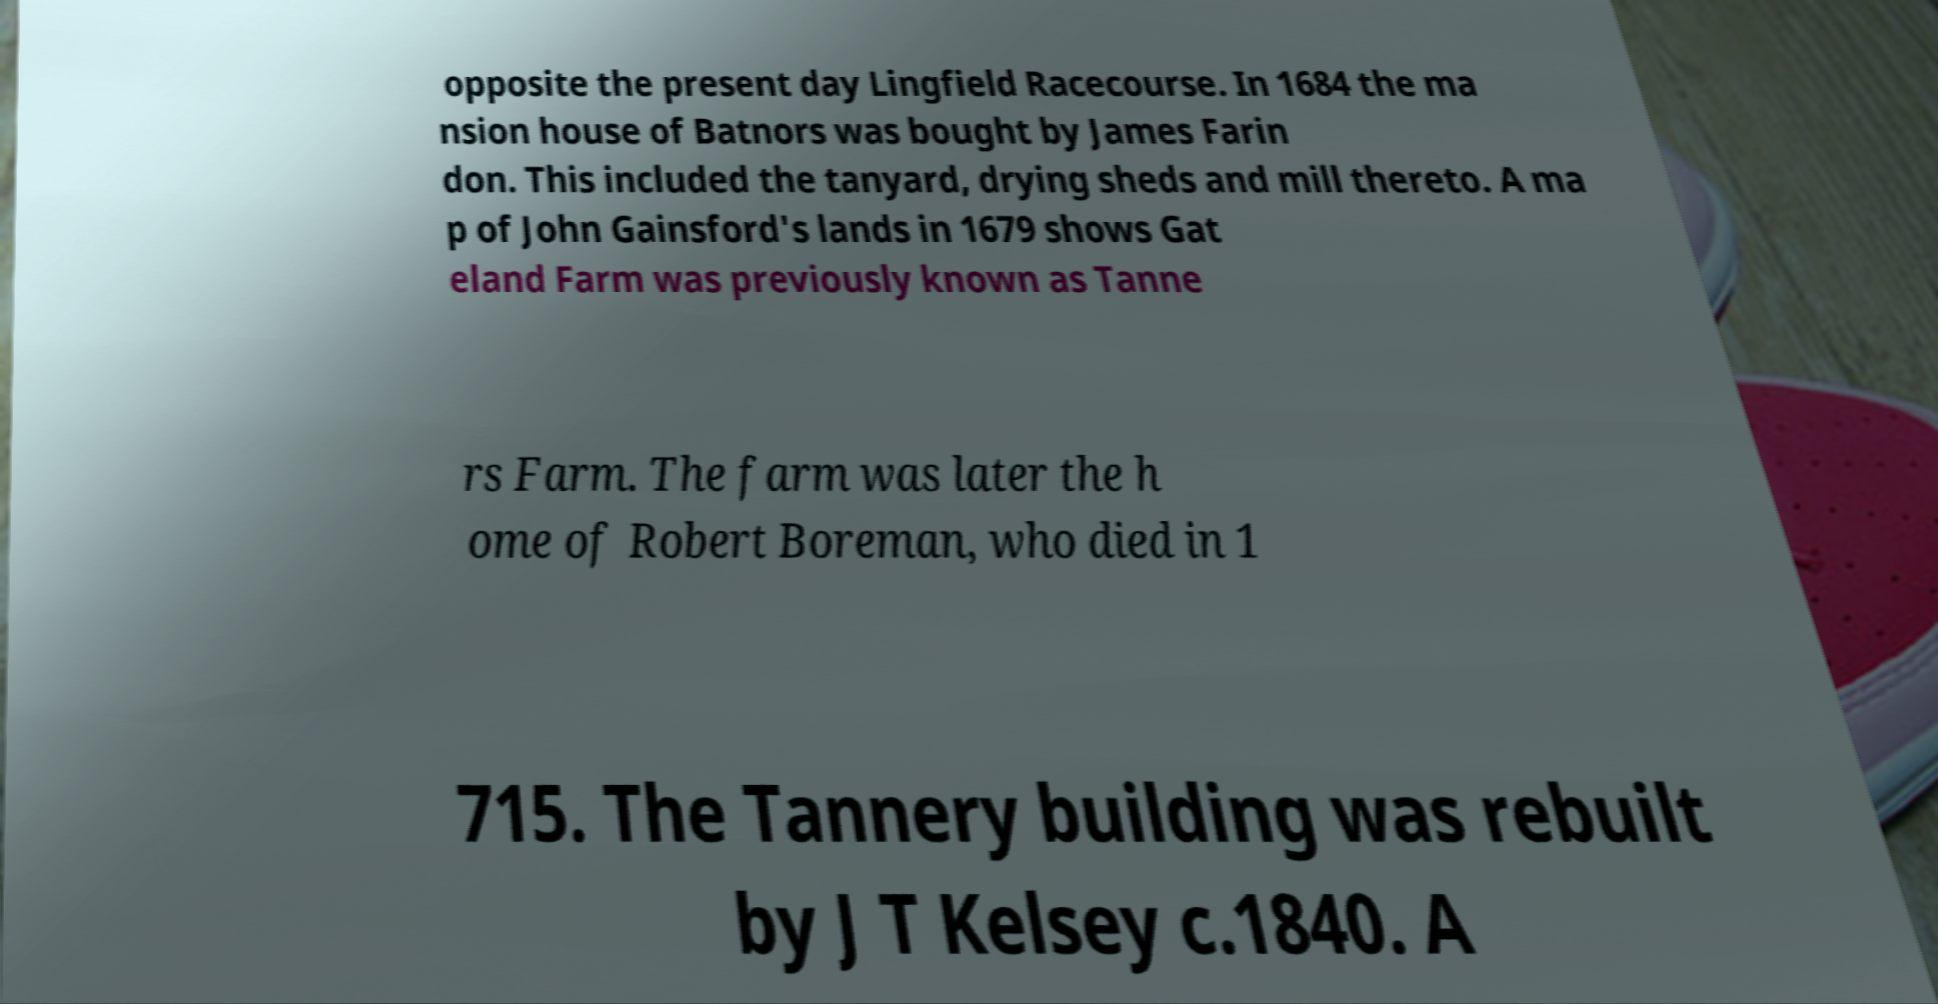Can you accurately transcribe the text from the provided image for me? opposite the present day Lingfield Racecourse. In 1684 the ma nsion house of Batnors was bought by James Farin don. This included the tanyard, drying sheds and mill thereto. A ma p of John Gainsford's lands in 1679 shows Gat eland Farm was previously known as Tanne rs Farm. The farm was later the h ome of Robert Boreman, who died in 1 715. The Tannery building was rebuilt by J T Kelsey c.1840. A 